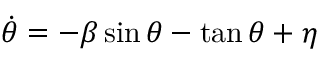<formula> <loc_0><loc_0><loc_500><loc_500>\dot { \theta } = - \beta \sin \theta - \tan \theta + \eta</formula> 